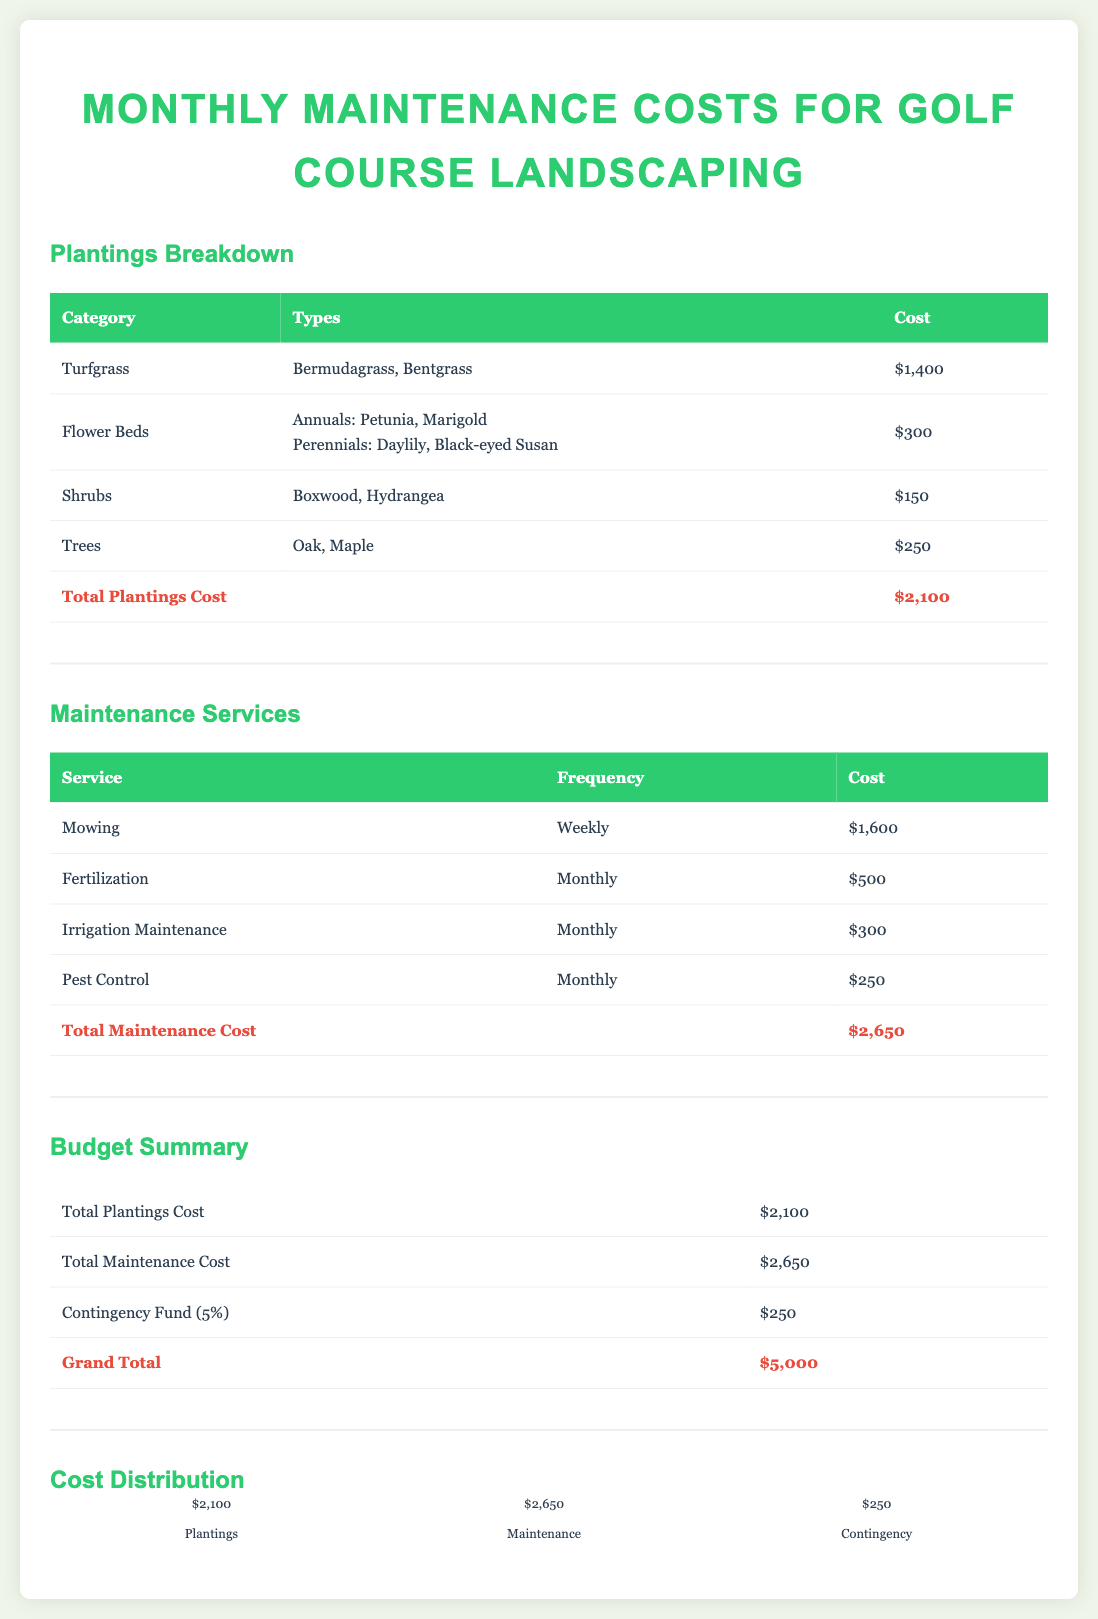What is the total cost for turfgrass? The cost for turfgrass is listed as $1,400 in the document.
Answer: $1,400 What types of flowers are included in the flower beds? The flower bed types include annuals (Petunia, Marigold) and perennials (Daylily, Black-eyed Susan).
Answer: Petunia, Marigold, Daylily, Black-eyed Susan How often is mowing performed? Mowing is indicated to occur on a weekly basis in the maintenance services section.
Answer: Weekly What is the total monthly maintenance cost? The total monthly maintenance cost is the sum of all maintenance services, which is $2,650.
Answer: $2,650 What percentage is allocated for the contingency fund? The contingency fund is specified to be 5% of the total budget in the summary section.
Answer: 5% How much is budgeted for trees? The budget for trees is listed as $250 in the plantings breakdown.
Answer: $250 Which category has the highest cost in plantings? Turfgrass has the highest cost at $1,400 according to the breakdown of plantings.
Answer: Turfgrass What is the grand total for the budget? The grand total for the budget is listed as $5,000 in the budget summary section.
Answer: $5,000 